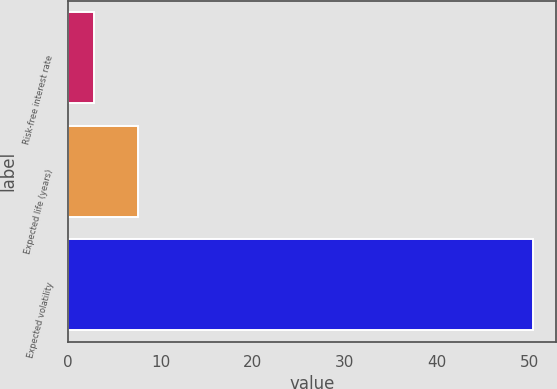Convert chart. <chart><loc_0><loc_0><loc_500><loc_500><bar_chart><fcel>Risk-free interest rate<fcel>Expected life (years)<fcel>Expected volatility<nl><fcel>2.77<fcel>7.53<fcel>50.4<nl></chart> 